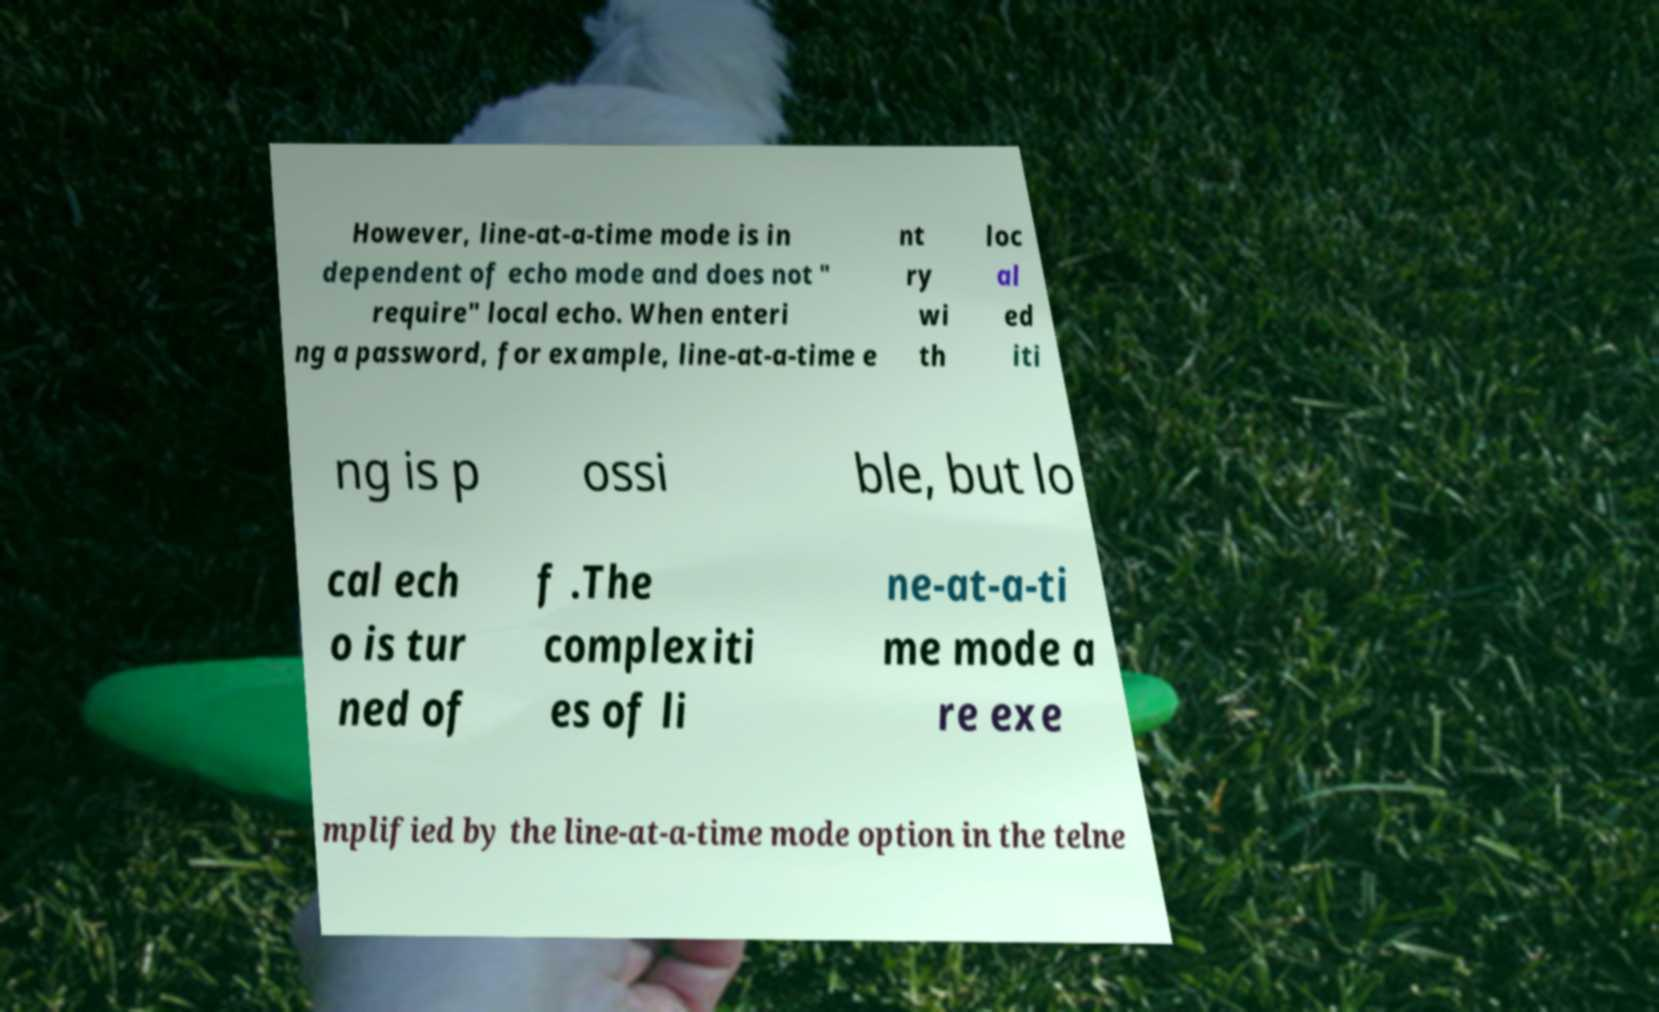Please read and relay the text visible in this image. What does it say? However, line-at-a-time mode is in dependent of echo mode and does not " require" local echo. When enteri ng a password, for example, line-at-a-time e nt ry wi th loc al ed iti ng is p ossi ble, but lo cal ech o is tur ned of f .The complexiti es of li ne-at-a-ti me mode a re exe mplified by the line-at-a-time mode option in the telne 